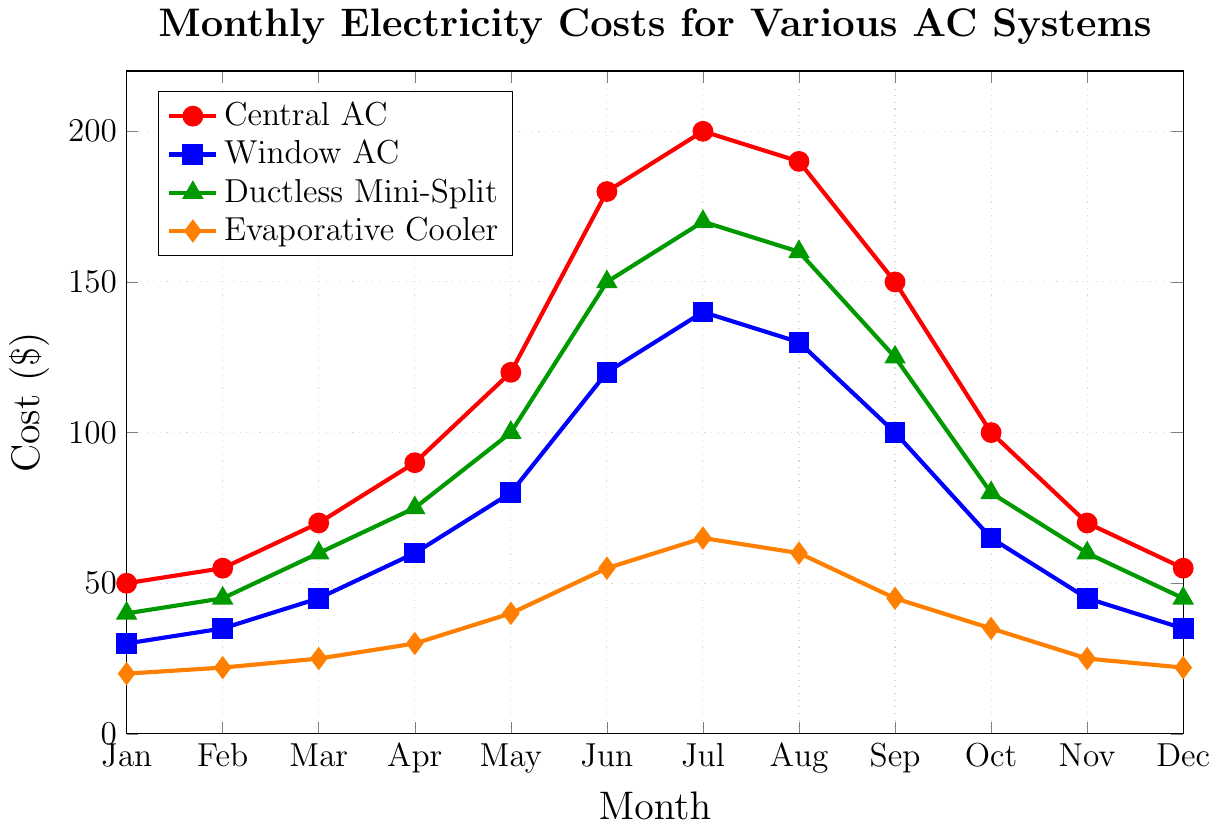What is the most expensive monthly electricity cost for Central AC and in which month does it occur? Look at the red line representing Central AC. The highest point of this line reaches $200, which occurs in July.
Answer: $200 in July Which cooling system has the lowest overall monthly electricity cost in January? Compare the points for January (x=0) across all cooling systems. The Evaporative Cooler (orange line) has the lowest cost at $20.
Answer: Evaporative Cooler ($20) On average, which cooling system is the most cost-effective throughout the year? Calculate the average monthly cost for each system: 
Central AC: (50 + 55 + 70 + 90 + 120 + 180 + 200 + 190 + 150 + 100 + 70 + 55) / 12 = 119.17 
Window AC: (30 + 35 + 45 + 60 + 80 + 120 + 140 + 130 + 100 + 65 + 45 + 35) / 12 = 73.33 
Ductless Mini-Split: (40 + 45 + 60 + 75 + 100 + 150 + 170 + 160 + 125 + 80 + 60 + 45) / 12 = 96.67 
Evaporative Cooler: (20 + 22 + 25 + 30 + 40 + 55 + 65 + 60 + 45 + 35 + 25 + 22) / 12 = 36.67 
The Evaporative Cooler has the lowest average cost.
Answer: Evaporative Cooler How many months does the Window AC have a lower cost than the Ductless Mini-Split? Compare the blue and green lines month by month. The Window AC has a lower cost in January, February, March, April, May, September, October, November, and December, making it 9 months in total.
Answer: 9 months How does the cost of Central AC in December compare to the cost of the same system in June? The cost for Central AC is $55 in December and $180 in June. The cost in June is ($180 - $55) = $125 higher than in December.
Answer: $125 higher Which month shows the highest overall cost across all cooling systems? Compare the top vertical points of all colored lines month by month. July shows the highest overall cost ($200 for Central AC).
Answer: July Compare the peak monthly costs of Window AC and Ductless Mini-Split systems. Which one is higher and by how much? The peak cost for Window AC is $140 in July, and for Ductless Mini-Split, it is $170 in July. The Ductless Mini-Split’s peak cost is higher by ($170 - $140) = $30.
Answer: Ductless Mini-Split by $30 Which air conditioning system shows the smallest cost variation throughout the year? Determine the range (max-min) for each system: 
Central AC: 200 - 50 = 150 
Window AC: 140 - 30 = 110 
Ductless Mini-Split: 170 - 40 = 130 
Evaporative Cooler: 65 - 20 = 45 
The Evaporative Cooler has the smallest variation.
Answer: Evaporative Cooler 